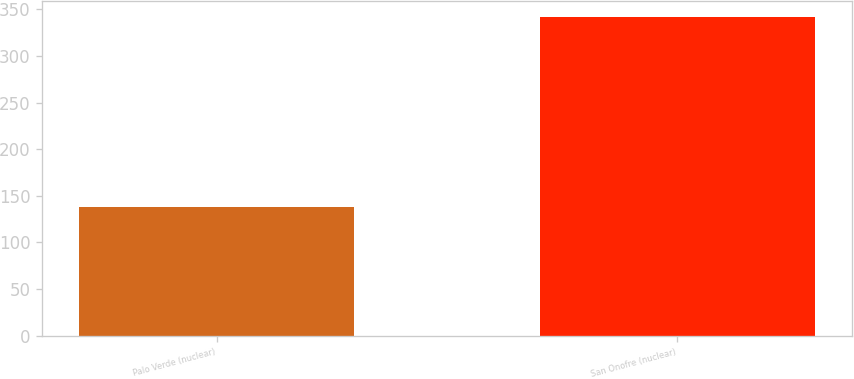Convert chart. <chart><loc_0><loc_0><loc_500><loc_500><bar_chart><fcel>Palo Verde (nuclear)<fcel>San Onofre (nuclear)<nl><fcel>138<fcel>342<nl></chart> 